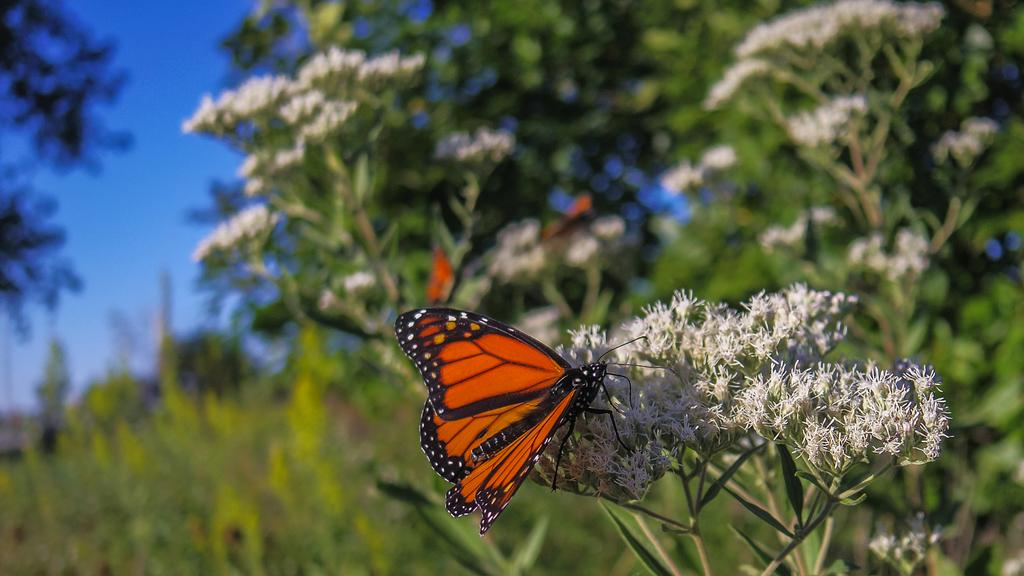What is the main subject of the image? The main subject of the image is a butterfly. Where is the butterfly located in the image? The butterfly is on flowers. What can be seen in the background of the image? There are trees and the sky visible in the background of the image. What type of punishment is being protested by the creature in the image? There is no creature present in the image, and therefore no protest or punishment can be observed. 